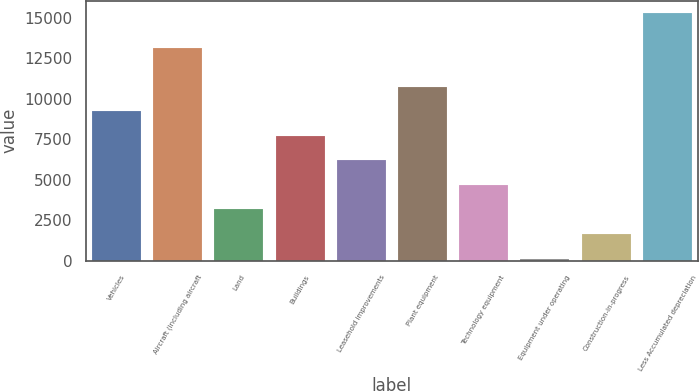Convert chart. <chart><loc_0><loc_0><loc_500><loc_500><bar_chart><fcel>Vehicles<fcel>Aircraft (including aircraft<fcel>Land<fcel>Buildings<fcel>Leasehold improvements<fcel>Plant equipment<fcel>Technology equipment<fcel>Equipment under operating<fcel>Construction-in-progress<fcel>Less Accumulated depreciation<nl><fcel>9238<fcel>13162<fcel>3174<fcel>7722<fcel>6206<fcel>10754<fcel>4690<fcel>142<fcel>1658<fcel>15302<nl></chart> 